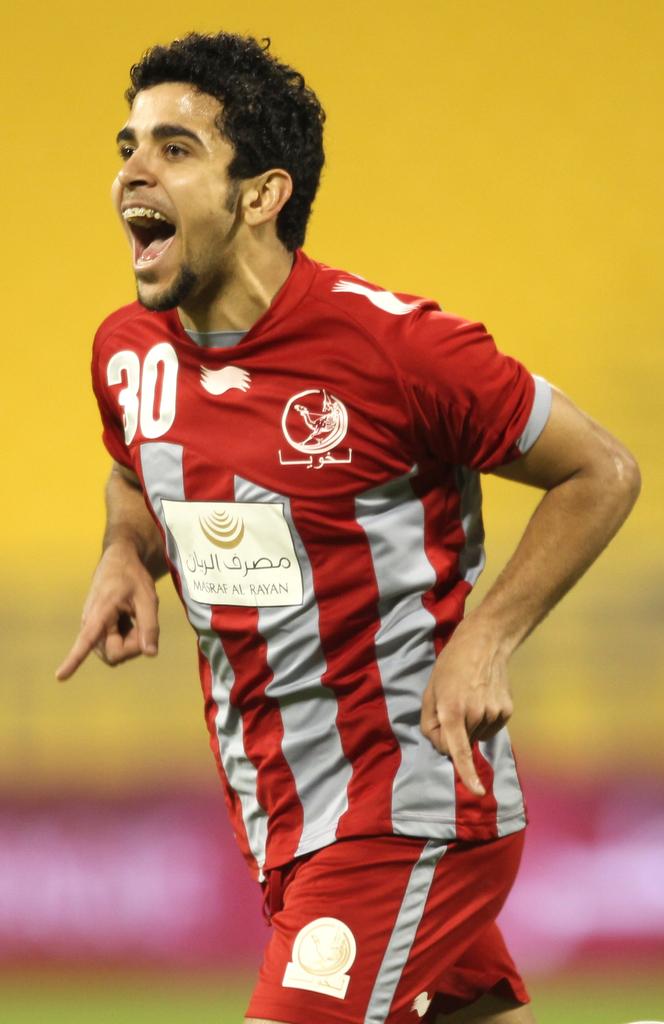What is the number of the athlete?
Your answer should be very brief. 30. What is printed on the last line of the white square on his shirt?
Ensure brevity in your answer.  Masraf al rayan. 